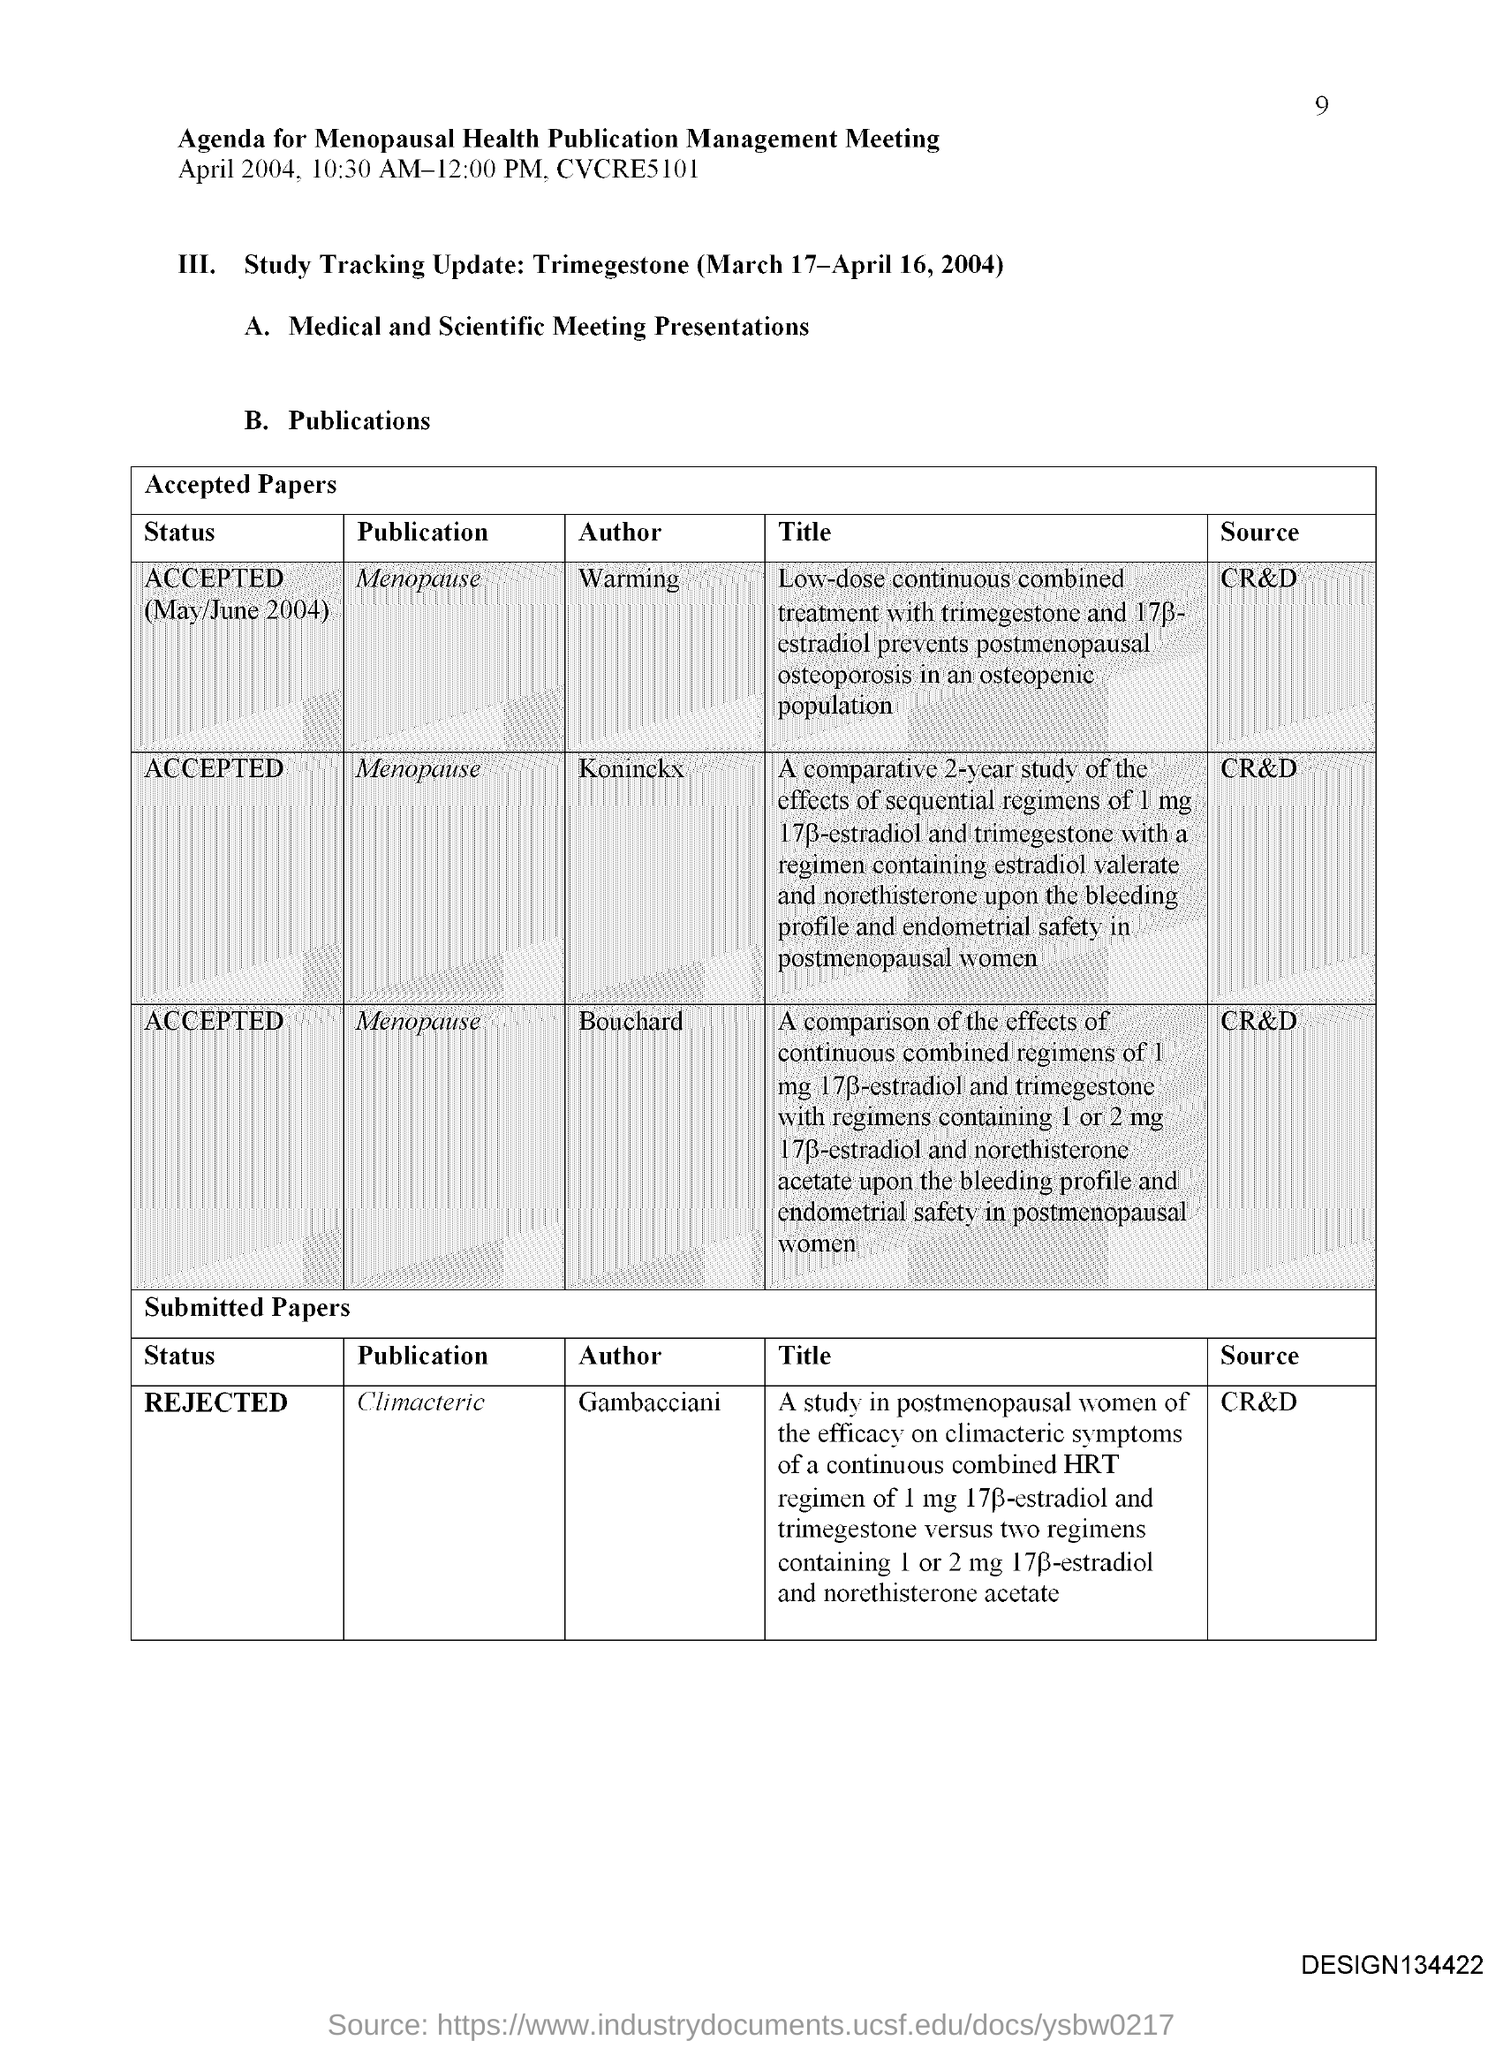Specify some key components in this picture. The page number mentioned in this document is 9. 